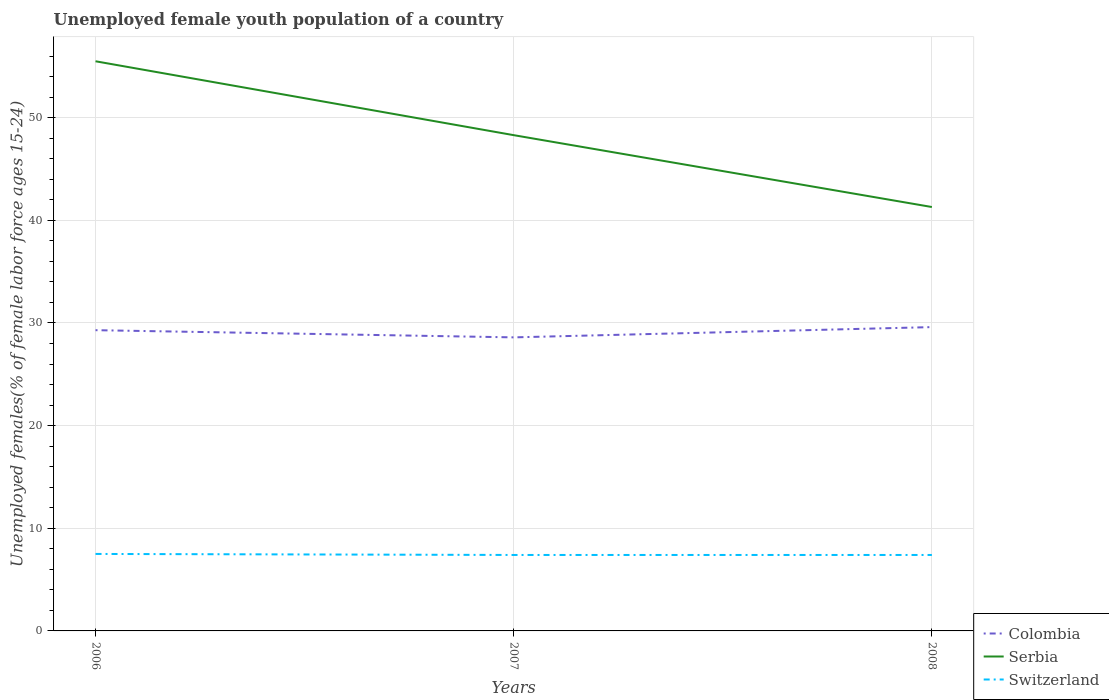How many different coloured lines are there?
Ensure brevity in your answer.  3. Does the line corresponding to Serbia intersect with the line corresponding to Switzerland?
Ensure brevity in your answer.  No. Is the number of lines equal to the number of legend labels?
Your answer should be very brief. Yes. Across all years, what is the maximum percentage of unemployed female youth population in Switzerland?
Ensure brevity in your answer.  7.4. In which year was the percentage of unemployed female youth population in Colombia maximum?
Your answer should be compact. 2007. What is the total percentage of unemployed female youth population in Serbia in the graph?
Your response must be concise. 14.2. What is the difference between the highest and the second highest percentage of unemployed female youth population in Switzerland?
Your answer should be compact. 0.1. What is the difference between the highest and the lowest percentage of unemployed female youth population in Colombia?
Your answer should be compact. 2. Is the percentage of unemployed female youth population in Serbia strictly greater than the percentage of unemployed female youth population in Switzerland over the years?
Your response must be concise. No. How many years are there in the graph?
Your answer should be very brief. 3. Does the graph contain any zero values?
Offer a very short reply. No. Where does the legend appear in the graph?
Your response must be concise. Bottom right. What is the title of the graph?
Offer a terse response. Unemployed female youth population of a country. What is the label or title of the Y-axis?
Ensure brevity in your answer.  Unemployed females(% of female labor force ages 15-24). What is the Unemployed females(% of female labor force ages 15-24) of Colombia in 2006?
Make the answer very short. 29.3. What is the Unemployed females(% of female labor force ages 15-24) in Serbia in 2006?
Ensure brevity in your answer.  55.5. What is the Unemployed females(% of female labor force ages 15-24) of Colombia in 2007?
Your answer should be very brief. 28.6. What is the Unemployed females(% of female labor force ages 15-24) in Serbia in 2007?
Provide a short and direct response. 48.3. What is the Unemployed females(% of female labor force ages 15-24) in Switzerland in 2007?
Give a very brief answer. 7.4. What is the Unemployed females(% of female labor force ages 15-24) of Colombia in 2008?
Ensure brevity in your answer.  29.6. What is the Unemployed females(% of female labor force ages 15-24) in Serbia in 2008?
Ensure brevity in your answer.  41.3. What is the Unemployed females(% of female labor force ages 15-24) in Switzerland in 2008?
Provide a short and direct response. 7.4. Across all years, what is the maximum Unemployed females(% of female labor force ages 15-24) of Colombia?
Offer a terse response. 29.6. Across all years, what is the maximum Unemployed females(% of female labor force ages 15-24) in Serbia?
Your response must be concise. 55.5. Across all years, what is the minimum Unemployed females(% of female labor force ages 15-24) of Colombia?
Your response must be concise. 28.6. Across all years, what is the minimum Unemployed females(% of female labor force ages 15-24) in Serbia?
Offer a very short reply. 41.3. Across all years, what is the minimum Unemployed females(% of female labor force ages 15-24) of Switzerland?
Provide a succinct answer. 7.4. What is the total Unemployed females(% of female labor force ages 15-24) of Colombia in the graph?
Offer a very short reply. 87.5. What is the total Unemployed females(% of female labor force ages 15-24) in Serbia in the graph?
Give a very brief answer. 145.1. What is the total Unemployed females(% of female labor force ages 15-24) in Switzerland in the graph?
Your answer should be compact. 22.3. What is the difference between the Unemployed females(% of female labor force ages 15-24) in Colombia in 2006 and that in 2007?
Ensure brevity in your answer.  0.7. What is the difference between the Unemployed females(% of female labor force ages 15-24) of Serbia in 2006 and that in 2007?
Your response must be concise. 7.2. What is the difference between the Unemployed females(% of female labor force ages 15-24) of Switzerland in 2006 and that in 2008?
Provide a short and direct response. 0.1. What is the difference between the Unemployed females(% of female labor force ages 15-24) of Serbia in 2007 and that in 2008?
Give a very brief answer. 7. What is the difference between the Unemployed females(% of female labor force ages 15-24) in Switzerland in 2007 and that in 2008?
Your answer should be very brief. 0. What is the difference between the Unemployed females(% of female labor force ages 15-24) of Colombia in 2006 and the Unemployed females(% of female labor force ages 15-24) of Serbia in 2007?
Your answer should be very brief. -19. What is the difference between the Unemployed females(% of female labor force ages 15-24) of Colombia in 2006 and the Unemployed females(% of female labor force ages 15-24) of Switzerland in 2007?
Give a very brief answer. 21.9. What is the difference between the Unemployed females(% of female labor force ages 15-24) of Serbia in 2006 and the Unemployed females(% of female labor force ages 15-24) of Switzerland in 2007?
Ensure brevity in your answer.  48.1. What is the difference between the Unemployed females(% of female labor force ages 15-24) in Colombia in 2006 and the Unemployed females(% of female labor force ages 15-24) in Serbia in 2008?
Your response must be concise. -12. What is the difference between the Unemployed females(% of female labor force ages 15-24) in Colombia in 2006 and the Unemployed females(% of female labor force ages 15-24) in Switzerland in 2008?
Offer a very short reply. 21.9. What is the difference between the Unemployed females(% of female labor force ages 15-24) of Serbia in 2006 and the Unemployed females(% of female labor force ages 15-24) of Switzerland in 2008?
Your answer should be compact. 48.1. What is the difference between the Unemployed females(% of female labor force ages 15-24) in Colombia in 2007 and the Unemployed females(% of female labor force ages 15-24) in Switzerland in 2008?
Your response must be concise. 21.2. What is the difference between the Unemployed females(% of female labor force ages 15-24) of Serbia in 2007 and the Unemployed females(% of female labor force ages 15-24) of Switzerland in 2008?
Your response must be concise. 40.9. What is the average Unemployed females(% of female labor force ages 15-24) in Colombia per year?
Your answer should be very brief. 29.17. What is the average Unemployed females(% of female labor force ages 15-24) in Serbia per year?
Your response must be concise. 48.37. What is the average Unemployed females(% of female labor force ages 15-24) of Switzerland per year?
Provide a short and direct response. 7.43. In the year 2006, what is the difference between the Unemployed females(% of female labor force ages 15-24) of Colombia and Unemployed females(% of female labor force ages 15-24) of Serbia?
Provide a short and direct response. -26.2. In the year 2006, what is the difference between the Unemployed females(% of female labor force ages 15-24) in Colombia and Unemployed females(% of female labor force ages 15-24) in Switzerland?
Give a very brief answer. 21.8. In the year 2007, what is the difference between the Unemployed females(% of female labor force ages 15-24) of Colombia and Unemployed females(% of female labor force ages 15-24) of Serbia?
Your response must be concise. -19.7. In the year 2007, what is the difference between the Unemployed females(% of female labor force ages 15-24) of Colombia and Unemployed females(% of female labor force ages 15-24) of Switzerland?
Your answer should be very brief. 21.2. In the year 2007, what is the difference between the Unemployed females(% of female labor force ages 15-24) in Serbia and Unemployed females(% of female labor force ages 15-24) in Switzerland?
Provide a short and direct response. 40.9. In the year 2008, what is the difference between the Unemployed females(% of female labor force ages 15-24) of Colombia and Unemployed females(% of female labor force ages 15-24) of Switzerland?
Give a very brief answer. 22.2. In the year 2008, what is the difference between the Unemployed females(% of female labor force ages 15-24) of Serbia and Unemployed females(% of female labor force ages 15-24) of Switzerland?
Offer a very short reply. 33.9. What is the ratio of the Unemployed females(% of female labor force ages 15-24) of Colombia in 2006 to that in 2007?
Your response must be concise. 1.02. What is the ratio of the Unemployed females(% of female labor force ages 15-24) in Serbia in 2006 to that in 2007?
Your answer should be very brief. 1.15. What is the ratio of the Unemployed females(% of female labor force ages 15-24) of Switzerland in 2006 to that in 2007?
Provide a short and direct response. 1.01. What is the ratio of the Unemployed females(% of female labor force ages 15-24) of Serbia in 2006 to that in 2008?
Ensure brevity in your answer.  1.34. What is the ratio of the Unemployed females(% of female labor force ages 15-24) in Switzerland in 2006 to that in 2008?
Your answer should be compact. 1.01. What is the ratio of the Unemployed females(% of female labor force ages 15-24) of Colombia in 2007 to that in 2008?
Keep it short and to the point. 0.97. What is the ratio of the Unemployed females(% of female labor force ages 15-24) in Serbia in 2007 to that in 2008?
Offer a very short reply. 1.17. What is the difference between the highest and the second highest Unemployed females(% of female labor force ages 15-24) of Switzerland?
Ensure brevity in your answer.  0.1. What is the difference between the highest and the lowest Unemployed females(% of female labor force ages 15-24) of Colombia?
Offer a very short reply. 1. What is the difference between the highest and the lowest Unemployed females(% of female labor force ages 15-24) in Switzerland?
Keep it short and to the point. 0.1. 